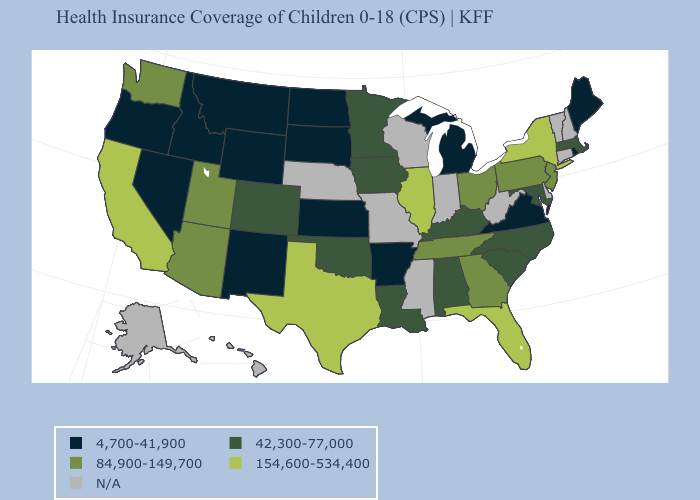Name the states that have a value in the range 42,300-77,000?
Keep it brief. Alabama, Colorado, Iowa, Kentucky, Louisiana, Maryland, Massachusetts, Minnesota, North Carolina, Oklahoma, South Carolina. What is the lowest value in the USA?
Concise answer only. 4,700-41,900. What is the lowest value in the USA?
Short answer required. 4,700-41,900. Does the map have missing data?
Concise answer only. Yes. Name the states that have a value in the range 4,700-41,900?
Give a very brief answer. Arkansas, Idaho, Kansas, Maine, Michigan, Montana, Nevada, New Mexico, North Dakota, Oregon, Rhode Island, South Dakota, Virginia, Wyoming. Which states have the lowest value in the USA?
Quick response, please. Arkansas, Idaho, Kansas, Maine, Michigan, Montana, Nevada, New Mexico, North Dakota, Oregon, Rhode Island, South Dakota, Virginia, Wyoming. Does Iowa have the highest value in the USA?
Short answer required. No. Among the states that border New Hampshire , does Maine have the lowest value?
Concise answer only. Yes. Which states have the lowest value in the West?
Keep it brief. Idaho, Montana, Nevada, New Mexico, Oregon, Wyoming. What is the value of Georgia?
Keep it brief. 84,900-149,700. What is the lowest value in the Northeast?
Keep it brief. 4,700-41,900. Name the states that have a value in the range 4,700-41,900?
Keep it brief. Arkansas, Idaho, Kansas, Maine, Michigan, Montana, Nevada, New Mexico, North Dakota, Oregon, Rhode Island, South Dakota, Virginia, Wyoming. How many symbols are there in the legend?
Concise answer only. 5. What is the value of Pennsylvania?
Keep it brief. 84,900-149,700. 